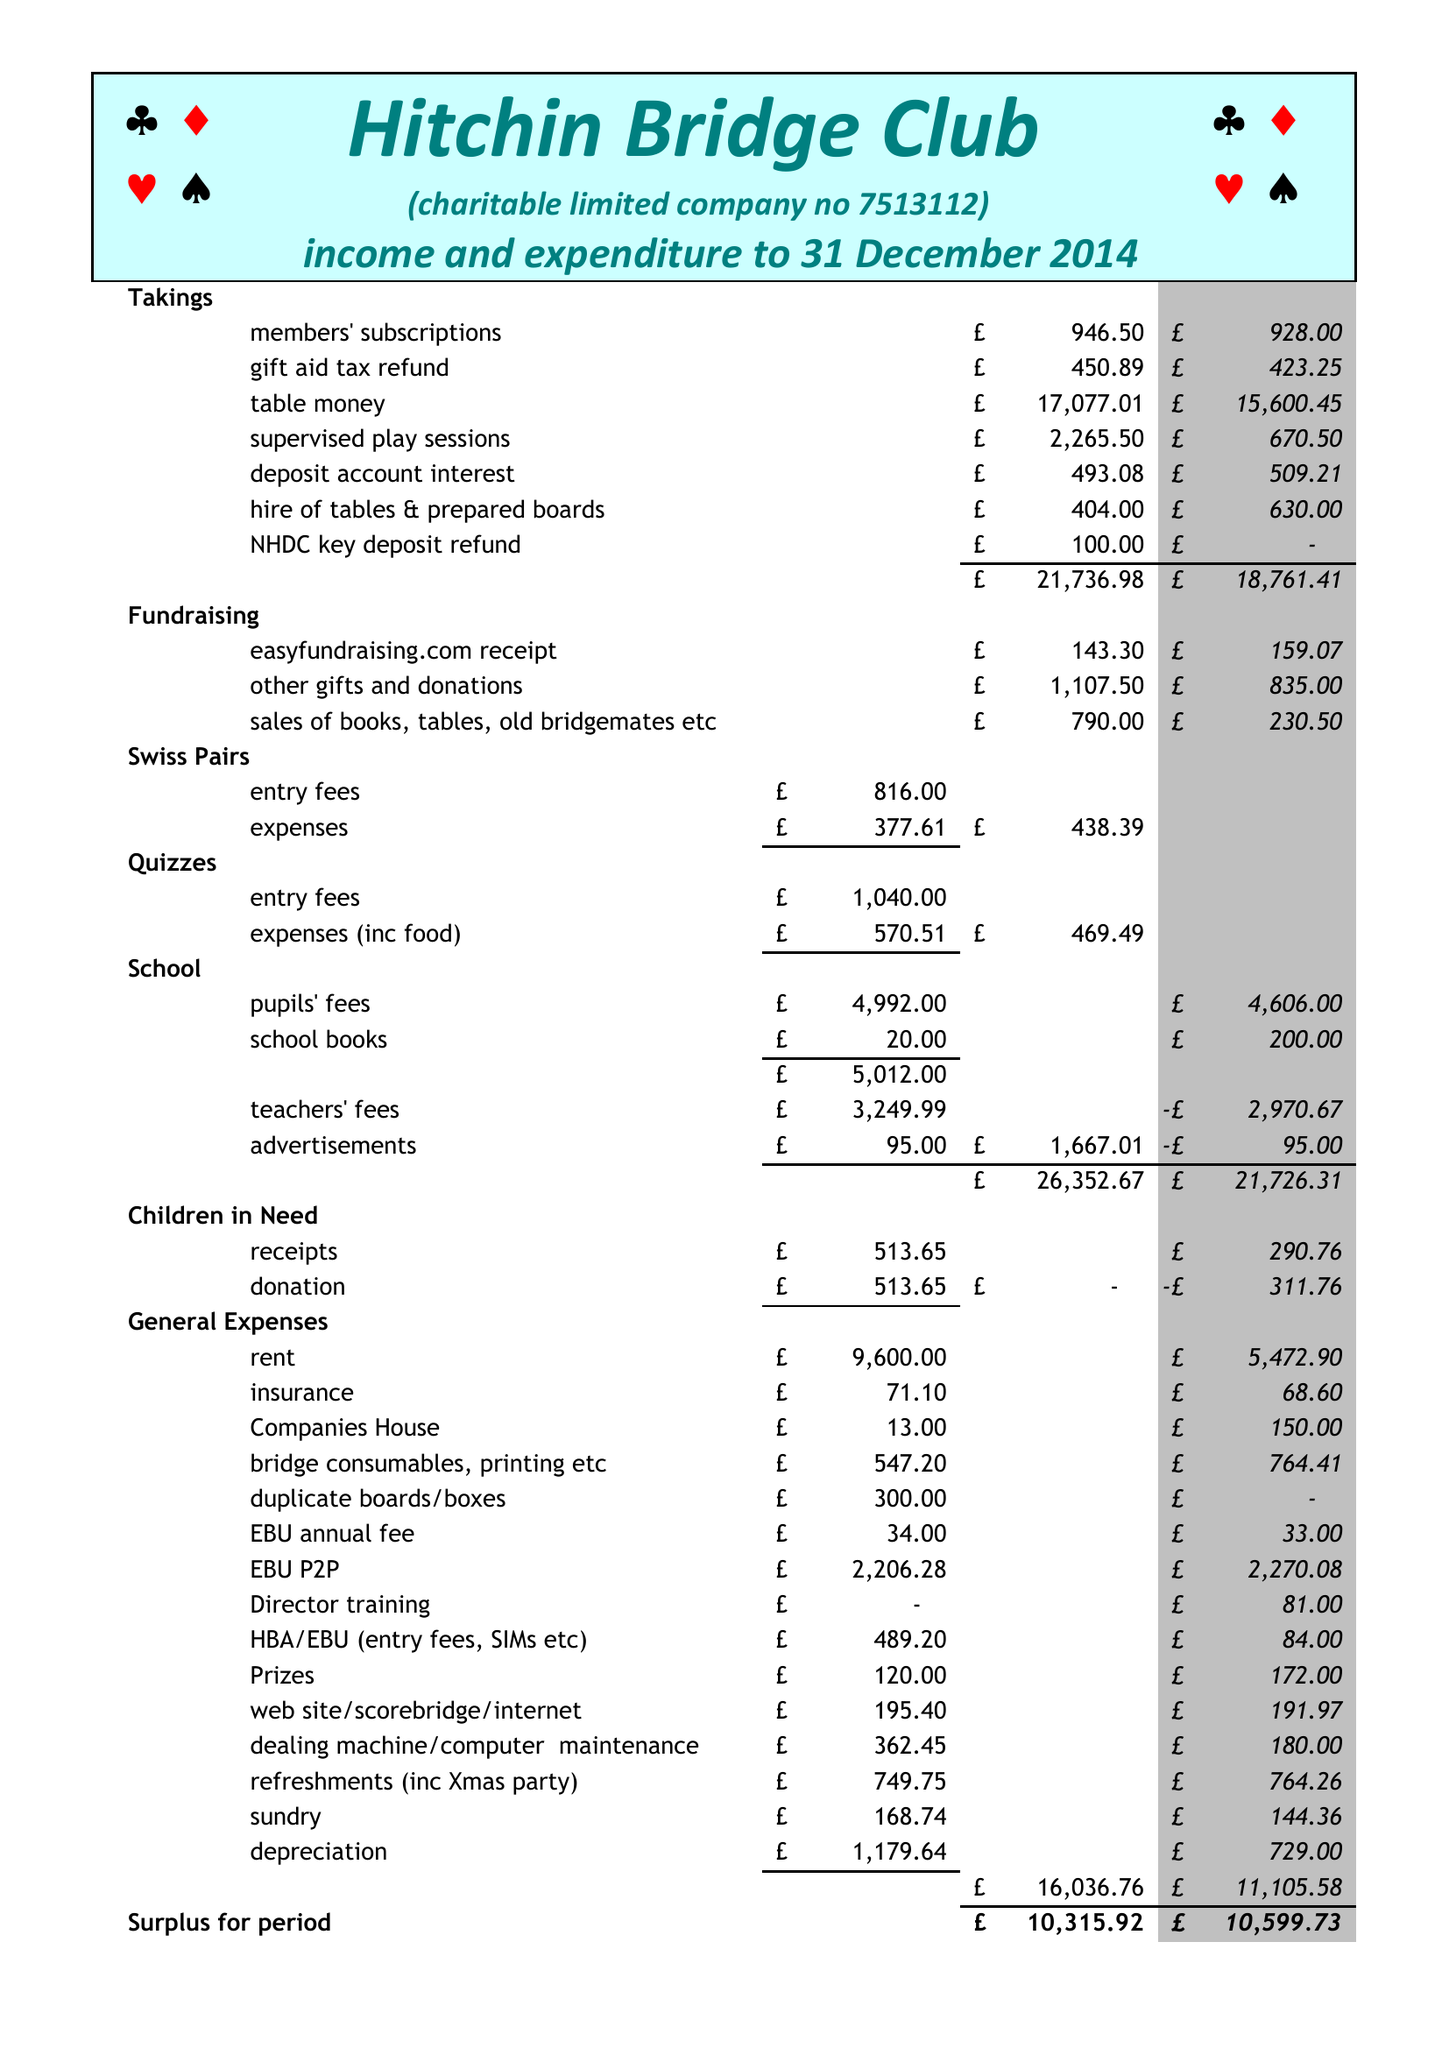What is the value for the charity_name?
Answer the question using a single word or phrase. Hitchin Bridge Club 